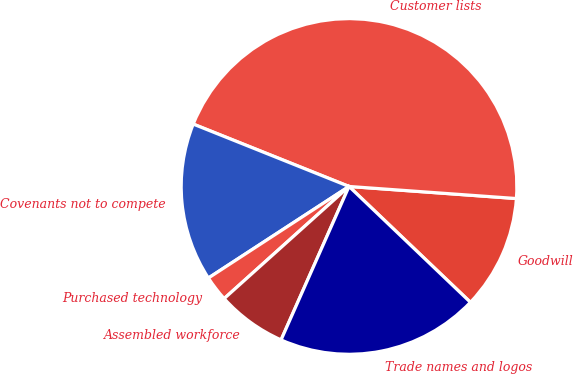<chart> <loc_0><loc_0><loc_500><loc_500><pie_chart><fcel>Goodwill<fcel>Customer lists<fcel>Covenants not to compete<fcel>Purchased technology<fcel>Assembled workforce<fcel>Trade names and logos<nl><fcel>10.98%<fcel>45.09%<fcel>15.25%<fcel>2.46%<fcel>6.72%<fcel>19.51%<nl></chart> 